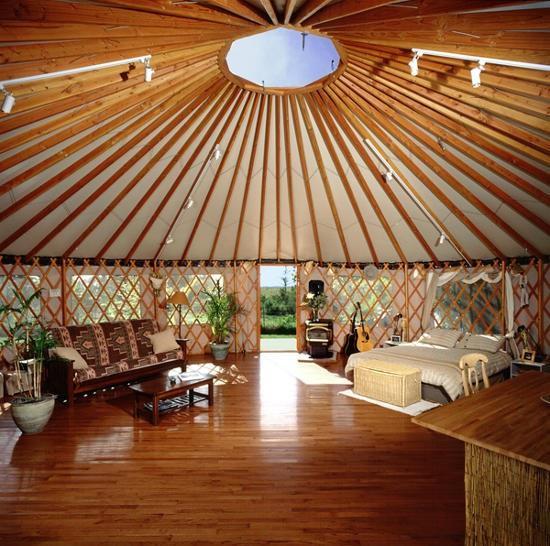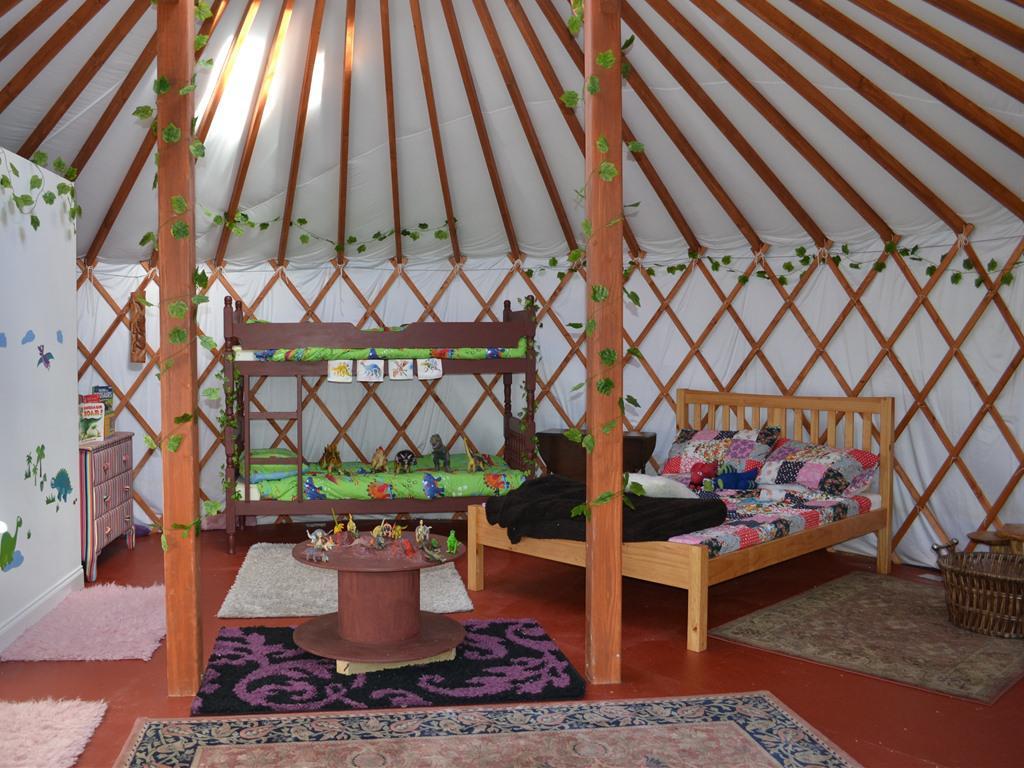The first image is the image on the left, the second image is the image on the right. Assess this claim about the two images: "The lefthand image shows a yurt interior with an animal hide used in the bedroom decor.". Correct or not? Answer yes or no. No. The first image is the image on the left, the second image is the image on the right. Evaluate the accuracy of this statement regarding the images: "In one image, an office area with an oak office chair on wheels and laptop computer is adjacent to the foot of a bed with an oriental rug on the floor.". Is it true? Answer yes or no. No. 